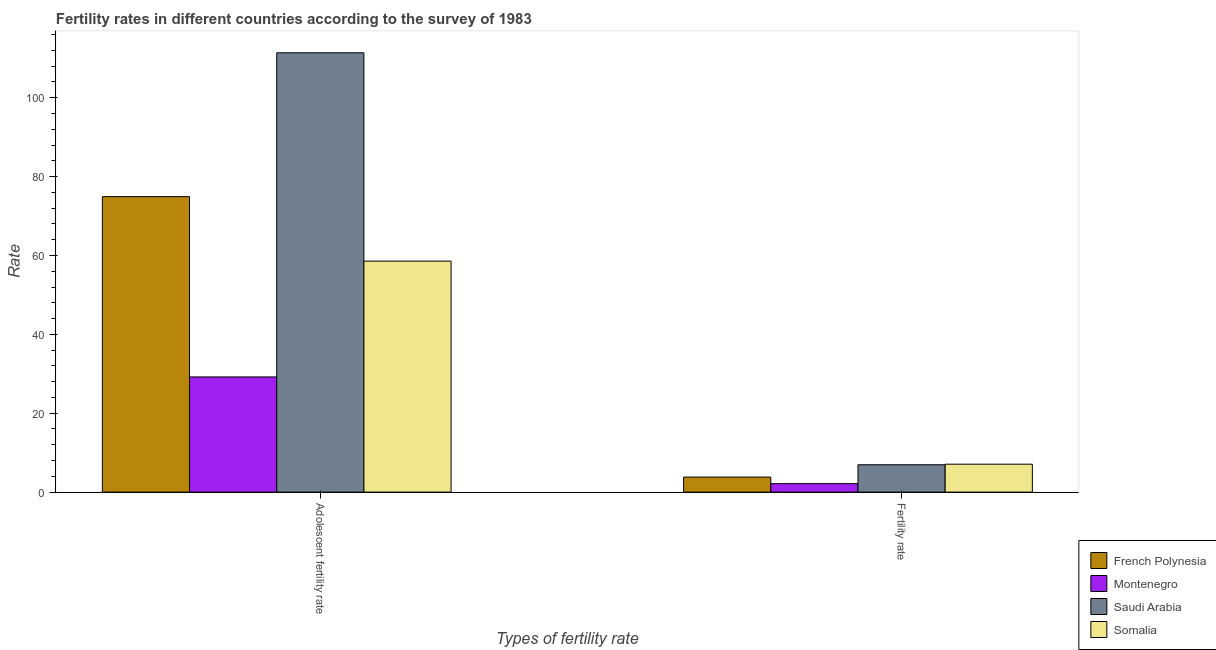How many different coloured bars are there?
Provide a short and direct response. 4. Are the number of bars per tick equal to the number of legend labels?
Give a very brief answer. Yes. Are the number of bars on each tick of the X-axis equal?
Offer a very short reply. Yes. How many bars are there on the 1st tick from the left?
Your answer should be very brief. 4. How many bars are there on the 1st tick from the right?
Give a very brief answer. 4. What is the label of the 2nd group of bars from the left?
Provide a succinct answer. Fertility rate. What is the fertility rate in Saudi Arabia?
Offer a terse response. 6.93. Across all countries, what is the maximum adolescent fertility rate?
Make the answer very short. 111.38. Across all countries, what is the minimum adolescent fertility rate?
Your response must be concise. 29.2. In which country was the adolescent fertility rate maximum?
Ensure brevity in your answer.  Saudi Arabia. In which country was the fertility rate minimum?
Keep it short and to the point. Montenegro. What is the total fertility rate in the graph?
Provide a succinct answer. 19.97. What is the difference between the fertility rate in Saudi Arabia and that in Somalia?
Provide a short and direct response. -0.15. What is the difference between the adolescent fertility rate in Montenegro and the fertility rate in Saudi Arabia?
Provide a succinct answer. 22.27. What is the average adolescent fertility rate per country?
Give a very brief answer. 68.51. What is the difference between the adolescent fertility rate and fertility rate in Montenegro?
Your answer should be compact. 27.05. In how many countries, is the fertility rate greater than 84 ?
Keep it short and to the point. 0. What is the ratio of the adolescent fertility rate in Somalia to that in Saudi Arabia?
Provide a succinct answer. 0.53. What does the 1st bar from the left in Adolescent fertility rate represents?
Provide a short and direct response. French Polynesia. What does the 3rd bar from the right in Adolescent fertility rate represents?
Provide a succinct answer. Montenegro. How many bars are there?
Provide a succinct answer. 8. How many countries are there in the graph?
Your response must be concise. 4. Does the graph contain any zero values?
Keep it short and to the point. No. Does the graph contain grids?
Give a very brief answer. No. Where does the legend appear in the graph?
Your response must be concise. Bottom right. How many legend labels are there?
Offer a very short reply. 4. How are the legend labels stacked?
Give a very brief answer. Vertical. What is the title of the graph?
Offer a terse response. Fertility rates in different countries according to the survey of 1983. Does "Marshall Islands" appear as one of the legend labels in the graph?
Ensure brevity in your answer.  No. What is the label or title of the X-axis?
Your answer should be compact. Types of fertility rate. What is the label or title of the Y-axis?
Offer a terse response. Rate. What is the Rate in French Polynesia in Adolescent fertility rate?
Make the answer very short. 74.91. What is the Rate of Montenegro in Adolescent fertility rate?
Offer a terse response. 29.2. What is the Rate of Saudi Arabia in Adolescent fertility rate?
Make the answer very short. 111.38. What is the Rate in Somalia in Adolescent fertility rate?
Your response must be concise. 58.57. What is the Rate of French Polynesia in Fertility rate?
Give a very brief answer. 3.81. What is the Rate of Montenegro in Fertility rate?
Provide a succinct answer. 2.15. What is the Rate of Saudi Arabia in Fertility rate?
Your response must be concise. 6.93. What is the Rate in Somalia in Fertility rate?
Offer a very short reply. 7.08. Across all Types of fertility rate, what is the maximum Rate of French Polynesia?
Your response must be concise. 74.91. Across all Types of fertility rate, what is the maximum Rate of Montenegro?
Ensure brevity in your answer.  29.2. Across all Types of fertility rate, what is the maximum Rate of Saudi Arabia?
Provide a short and direct response. 111.38. Across all Types of fertility rate, what is the maximum Rate of Somalia?
Offer a terse response. 58.57. Across all Types of fertility rate, what is the minimum Rate in French Polynesia?
Provide a succinct answer. 3.81. Across all Types of fertility rate, what is the minimum Rate in Montenegro?
Make the answer very short. 2.15. Across all Types of fertility rate, what is the minimum Rate in Saudi Arabia?
Provide a short and direct response. 6.93. Across all Types of fertility rate, what is the minimum Rate in Somalia?
Offer a terse response. 7.08. What is the total Rate in French Polynesia in the graph?
Your response must be concise. 78.72. What is the total Rate of Montenegro in the graph?
Give a very brief answer. 31.34. What is the total Rate in Saudi Arabia in the graph?
Ensure brevity in your answer.  118.31. What is the total Rate of Somalia in the graph?
Your response must be concise. 65.65. What is the difference between the Rate in French Polynesia in Adolescent fertility rate and that in Fertility rate?
Offer a terse response. 71.1. What is the difference between the Rate of Montenegro in Adolescent fertility rate and that in Fertility rate?
Your response must be concise. 27.05. What is the difference between the Rate of Saudi Arabia in Adolescent fertility rate and that in Fertility rate?
Offer a very short reply. 104.45. What is the difference between the Rate of Somalia in Adolescent fertility rate and that in Fertility rate?
Provide a short and direct response. 51.49. What is the difference between the Rate in French Polynesia in Adolescent fertility rate and the Rate in Montenegro in Fertility rate?
Your answer should be very brief. 72.76. What is the difference between the Rate of French Polynesia in Adolescent fertility rate and the Rate of Saudi Arabia in Fertility rate?
Provide a succinct answer. 67.97. What is the difference between the Rate in French Polynesia in Adolescent fertility rate and the Rate in Somalia in Fertility rate?
Provide a short and direct response. 67.83. What is the difference between the Rate in Montenegro in Adolescent fertility rate and the Rate in Saudi Arabia in Fertility rate?
Offer a terse response. 22.27. What is the difference between the Rate of Montenegro in Adolescent fertility rate and the Rate of Somalia in Fertility rate?
Your response must be concise. 22.12. What is the difference between the Rate in Saudi Arabia in Adolescent fertility rate and the Rate in Somalia in Fertility rate?
Keep it short and to the point. 104.3. What is the average Rate in French Polynesia per Types of fertility rate?
Offer a very short reply. 39.36. What is the average Rate of Montenegro per Types of fertility rate?
Offer a terse response. 15.67. What is the average Rate of Saudi Arabia per Types of fertility rate?
Your response must be concise. 59.16. What is the average Rate of Somalia per Types of fertility rate?
Offer a very short reply. 32.82. What is the difference between the Rate in French Polynesia and Rate in Montenegro in Adolescent fertility rate?
Provide a succinct answer. 45.71. What is the difference between the Rate of French Polynesia and Rate of Saudi Arabia in Adolescent fertility rate?
Make the answer very short. -36.47. What is the difference between the Rate in French Polynesia and Rate in Somalia in Adolescent fertility rate?
Your answer should be compact. 16.34. What is the difference between the Rate of Montenegro and Rate of Saudi Arabia in Adolescent fertility rate?
Offer a very short reply. -82.18. What is the difference between the Rate of Montenegro and Rate of Somalia in Adolescent fertility rate?
Make the answer very short. -29.37. What is the difference between the Rate in Saudi Arabia and Rate in Somalia in Adolescent fertility rate?
Keep it short and to the point. 52.81. What is the difference between the Rate in French Polynesia and Rate in Montenegro in Fertility rate?
Your answer should be very brief. 1.67. What is the difference between the Rate in French Polynesia and Rate in Saudi Arabia in Fertility rate?
Give a very brief answer. -3.12. What is the difference between the Rate of French Polynesia and Rate of Somalia in Fertility rate?
Make the answer very short. -3.27. What is the difference between the Rate of Montenegro and Rate of Saudi Arabia in Fertility rate?
Give a very brief answer. -4.79. What is the difference between the Rate of Montenegro and Rate of Somalia in Fertility rate?
Offer a terse response. -4.93. What is the difference between the Rate in Saudi Arabia and Rate in Somalia in Fertility rate?
Keep it short and to the point. -0.15. What is the ratio of the Rate in French Polynesia in Adolescent fertility rate to that in Fertility rate?
Offer a terse response. 19.65. What is the ratio of the Rate in Montenegro in Adolescent fertility rate to that in Fertility rate?
Offer a terse response. 13.61. What is the ratio of the Rate of Saudi Arabia in Adolescent fertility rate to that in Fertility rate?
Ensure brevity in your answer.  16.07. What is the ratio of the Rate in Somalia in Adolescent fertility rate to that in Fertility rate?
Make the answer very short. 8.27. What is the difference between the highest and the second highest Rate in French Polynesia?
Offer a terse response. 71.1. What is the difference between the highest and the second highest Rate in Montenegro?
Keep it short and to the point. 27.05. What is the difference between the highest and the second highest Rate in Saudi Arabia?
Offer a terse response. 104.45. What is the difference between the highest and the second highest Rate of Somalia?
Offer a very short reply. 51.49. What is the difference between the highest and the lowest Rate in French Polynesia?
Your answer should be very brief. 71.1. What is the difference between the highest and the lowest Rate in Montenegro?
Your response must be concise. 27.05. What is the difference between the highest and the lowest Rate of Saudi Arabia?
Your response must be concise. 104.45. What is the difference between the highest and the lowest Rate of Somalia?
Your response must be concise. 51.49. 